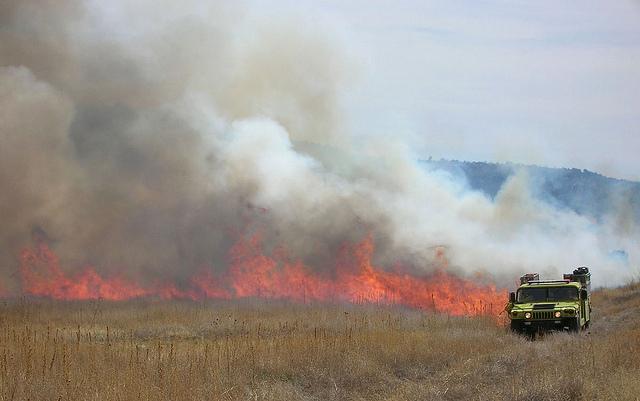What's causing the white vapor?
Concise answer only. Fire. What is the vehicle called?
Short answer required. Jeep. What color is the vehicle?
Give a very brief answer. Green. Why is there so much smoke?
Be succinct. Fire. Where is the black smoke coming from?
Give a very brief answer. Fire. What is causing the smoke in the photo?
Concise answer only. Fire. Is this a freight train?
Concise answer only. No. 